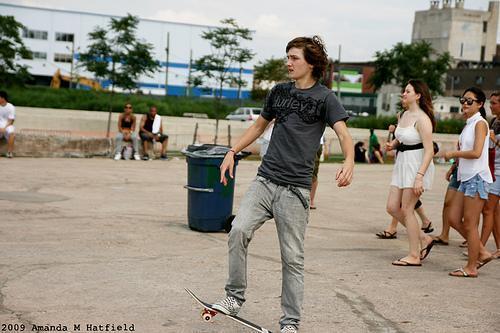How many people can be seen?
Give a very brief answer. 3. 